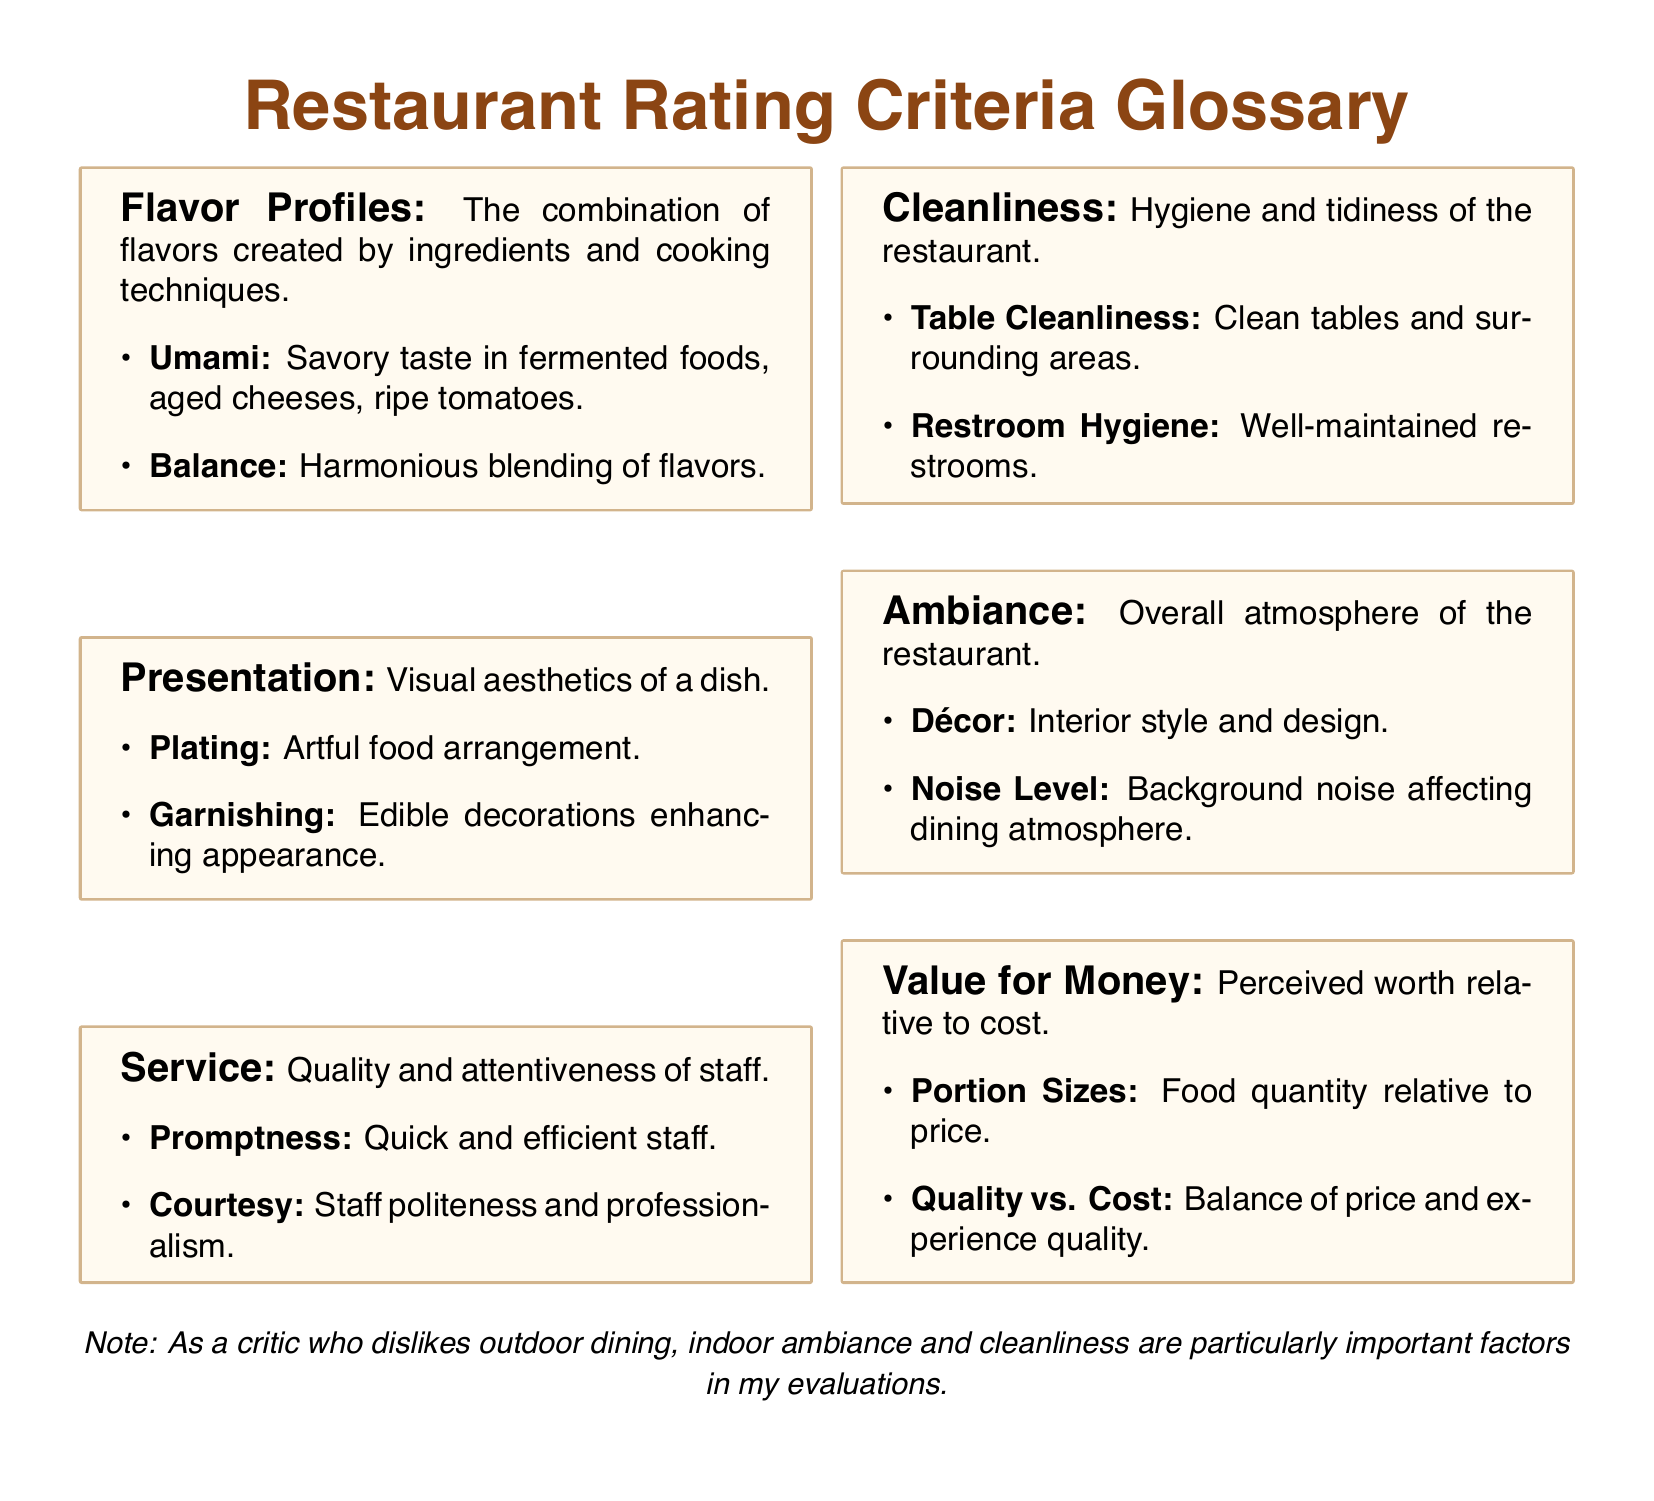What are the main criteria used to evaluate restaurants? The main criteria are Flavor Profiles, Presentation, Service, Cleanliness, Ambiance, and Value for Money.
Answer: Flavor Profiles, Presentation, Service, Cleanliness, Ambiance, Value for Money What is an example of an umami flavor? An umami flavor example includes aged cheeses.
Answer: Aged cheeses What does presentation refer to in restaurant evaluation? Presentation refers to the visual aesthetics of a dish.
Answer: Visual aesthetics What factor is considered under cleanliness? One factor under cleanliness is restroom hygiene.
Answer: Restroom hygiene What does value for money assess? Value for money assesses the perceived worth relative to cost.
Answer: Perceived worth relative to cost What aspect of service pertains to staff speed? The aspect of service that pertains to staff speed is promptness.
Answer: Promptness Which criterion includes the decor of the restaurant? The criterion that includes the decor of the restaurant is ambiance.
Answer: Ambiance What is indicated as particularly important in evaluations for the critic? Indoor ambiance and cleanliness are particularly important factors in evaluations.
Answer: Indoor ambiance and cleanliness 